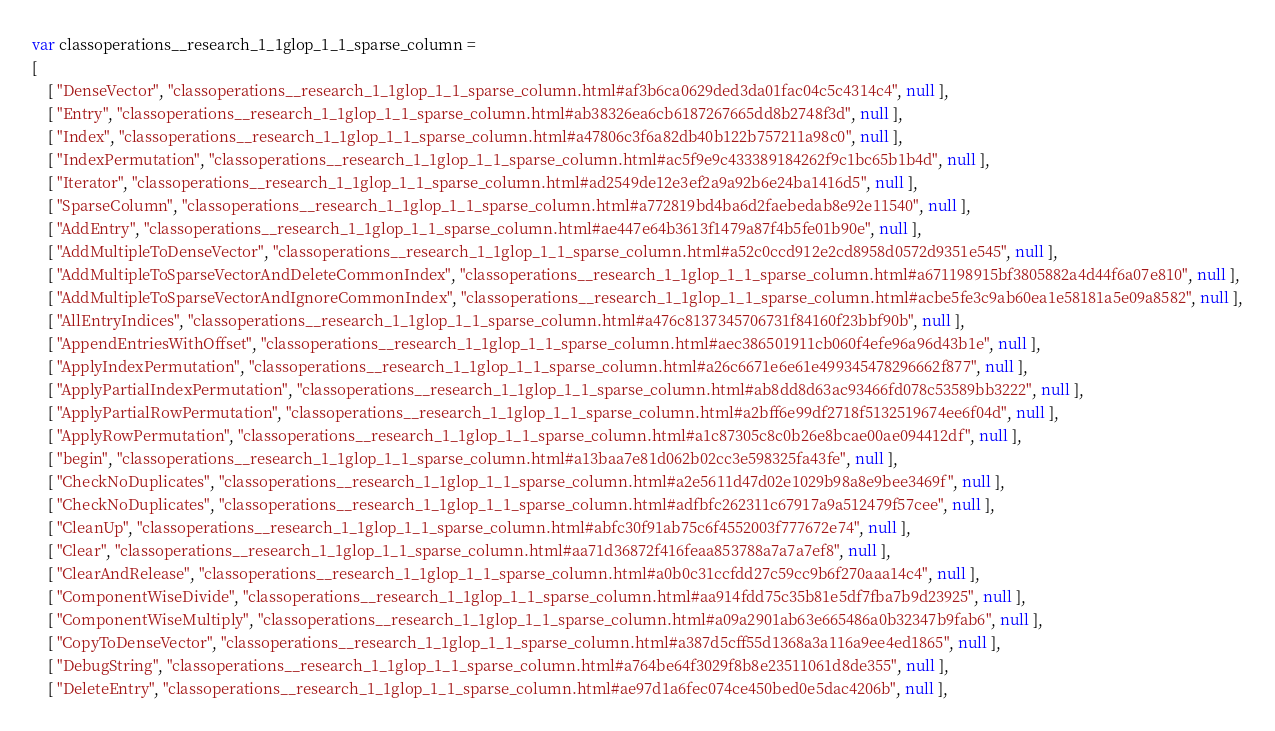<code> <loc_0><loc_0><loc_500><loc_500><_JavaScript_>var classoperations__research_1_1glop_1_1_sparse_column =
[
    [ "DenseVector", "classoperations__research_1_1glop_1_1_sparse_column.html#af3b6ca0629ded3da01fac04c5c4314c4", null ],
    [ "Entry", "classoperations__research_1_1glop_1_1_sparse_column.html#ab38326ea6cb6187267665dd8b2748f3d", null ],
    [ "Index", "classoperations__research_1_1glop_1_1_sparse_column.html#a47806c3f6a82db40b122b757211a98c0", null ],
    [ "IndexPermutation", "classoperations__research_1_1glop_1_1_sparse_column.html#ac5f9e9c433389184262f9c1bc65b1b4d", null ],
    [ "Iterator", "classoperations__research_1_1glop_1_1_sparse_column.html#ad2549de12e3ef2a9a92b6e24ba1416d5", null ],
    [ "SparseColumn", "classoperations__research_1_1glop_1_1_sparse_column.html#a772819bd4ba6d2faebedab8e92e11540", null ],
    [ "AddEntry", "classoperations__research_1_1glop_1_1_sparse_column.html#ae447e64b3613f1479a87f4b5fe01b90e", null ],
    [ "AddMultipleToDenseVector", "classoperations__research_1_1glop_1_1_sparse_column.html#a52c0ccd912e2cd8958d0572d9351e545", null ],
    [ "AddMultipleToSparseVectorAndDeleteCommonIndex", "classoperations__research_1_1glop_1_1_sparse_column.html#a671198915bf3805882a4d44f6a07e810", null ],
    [ "AddMultipleToSparseVectorAndIgnoreCommonIndex", "classoperations__research_1_1glop_1_1_sparse_column.html#acbe5fe3c9ab60ea1e58181a5e09a8582", null ],
    [ "AllEntryIndices", "classoperations__research_1_1glop_1_1_sparse_column.html#a476c8137345706731f84160f23bbf90b", null ],
    [ "AppendEntriesWithOffset", "classoperations__research_1_1glop_1_1_sparse_column.html#aec386501911cb060f4efe96a96d43b1e", null ],
    [ "ApplyIndexPermutation", "classoperations__research_1_1glop_1_1_sparse_column.html#a26c6671e6e61e499345478296662f877", null ],
    [ "ApplyPartialIndexPermutation", "classoperations__research_1_1glop_1_1_sparse_column.html#ab8dd8d63ac93466fd078c53589bb3222", null ],
    [ "ApplyPartialRowPermutation", "classoperations__research_1_1glop_1_1_sparse_column.html#a2bff6e99df2718f5132519674ee6f04d", null ],
    [ "ApplyRowPermutation", "classoperations__research_1_1glop_1_1_sparse_column.html#a1c87305c8c0b26e8bcae00ae094412df", null ],
    [ "begin", "classoperations__research_1_1glop_1_1_sparse_column.html#a13baa7e81d062b02cc3e598325fa43fe", null ],
    [ "CheckNoDuplicates", "classoperations__research_1_1glop_1_1_sparse_column.html#a2e5611d47d02e1029b98a8e9bee3469f", null ],
    [ "CheckNoDuplicates", "classoperations__research_1_1glop_1_1_sparse_column.html#adfbfc262311c67917a9a512479f57cee", null ],
    [ "CleanUp", "classoperations__research_1_1glop_1_1_sparse_column.html#abfc30f91ab75c6f4552003f777672e74", null ],
    [ "Clear", "classoperations__research_1_1glop_1_1_sparse_column.html#aa71d36872f416feaa853788a7a7a7ef8", null ],
    [ "ClearAndRelease", "classoperations__research_1_1glop_1_1_sparse_column.html#a0b0c31ccfdd27c59cc9b6f270aaa14c4", null ],
    [ "ComponentWiseDivide", "classoperations__research_1_1glop_1_1_sparse_column.html#aa914fdd75c35b81e5df7fba7b9d23925", null ],
    [ "ComponentWiseMultiply", "classoperations__research_1_1glop_1_1_sparse_column.html#a09a2901ab63e665486a0b32347b9fab6", null ],
    [ "CopyToDenseVector", "classoperations__research_1_1glop_1_1_sparse_column.html#a387d5cff55d1368a3a116a9ee4ed1865", null ],
    [ "DebugString", "classoperations__research_1_1glop_1_1_sparse_column.html#a764be64f3029f8b8e23511061d8de355", null ],
    [ "DeleteEntry", "classoperations__research_1_1glop_1_1_sparse_column.html#ae97d1a6fec074ce450bed0e5dac4206b", null ],</code> 